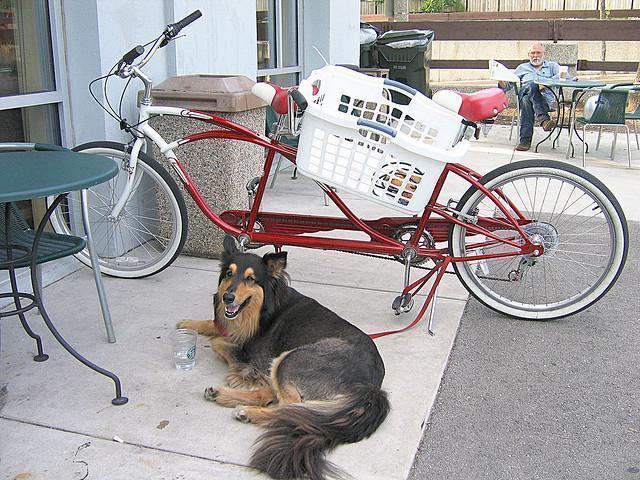What is the bike being used to transport?
Make your selection from the four choices given to correctly answer the question.
Options: Mail, hamper, dogs, water. Hamper. 